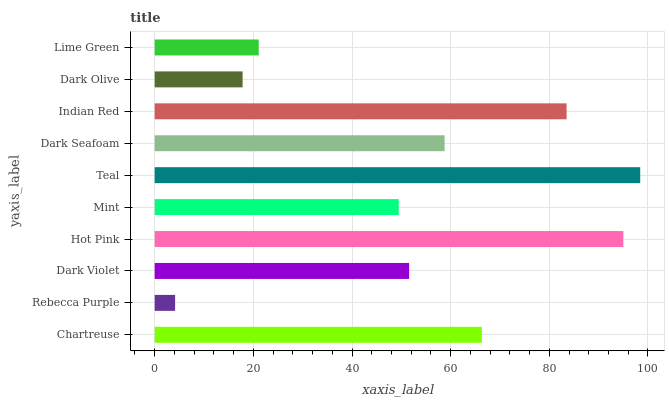Is Rebecca Purple the minimum?
Answer yes or no. Yes. Is Teal the maximum?
Answer yes or no. Yes. Is Dark Violet the minimum?
Answer yes or no. No. Is Dark Violet the maximum?
Answer yes or no. No. Is Dark Violet greater than Rebecca Purple?
Answer yes or no. Yes. Is Rebecca Purple less than Dark Violet?
Answer yes or no. Yes. Is Rebecca Purple greater than Dark Violet?
Answer yes or no. No. Is Dark Violet less than Rebecca Purple?
Answer yes or no. No. Is Dark Seafoam the high median?
Answer yes or no. Yes. Is Dark Violet the low median?
Answer yes or no. Yes. Is Hot Pink the high median?
Answer yes or no. No. Is Teal the low median?
Answer yes or no. No. 